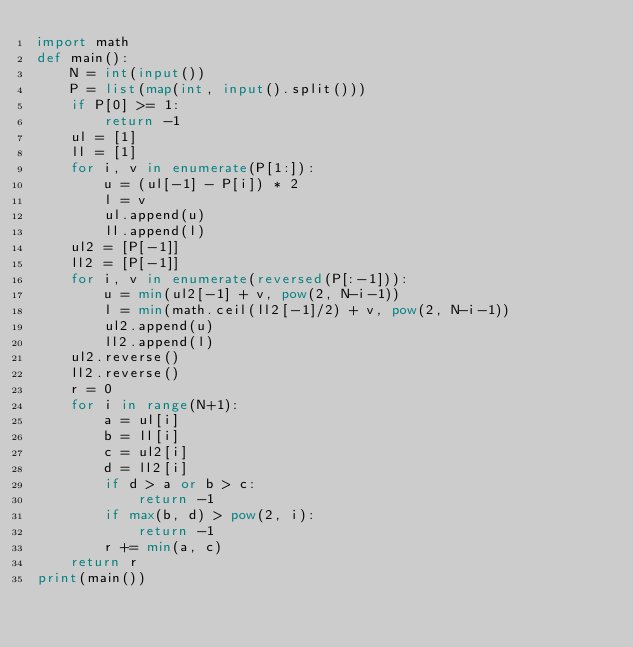<code> <loc_0><loc_0><loc_500><loc_500><_Python_>import math
def main():
    N = int(input())
    P = list(map(int, input().split()))
    if P[0] >= 1:
        return -1
    ul = [1]
    ll = [1]
    for i, v in enumerate(P[1:]):
        u = (ul[-1] - P[i]) * 2
        l = v
        ul.append(u)
        ll.append(l)
    ul2 = [P[-1]]
    ll2 = [P[-1]]
    for i, v in enumerate(reversed(P[:-1])):
        u = min(ul2[-1] + v, pow(2, N-i-1))
        l = min(math.ceil(ll2[-1]/2) + v, pow(2, N-i-1))
        ul2.append(u)
        ll2.append(l)
    ul2.reverse()
    ll2.reverse()
    r = 0
    for i in range(N+1):
        a = ul[i]
        b = ll[i]
        c = ul2[i]
        d = ll2[i]
        if d > a or b > c:
            return -1
        if max(b, d) > pow(2, i):
            return -1
        r += min(a, c)
    return r
print(main())
</code> 